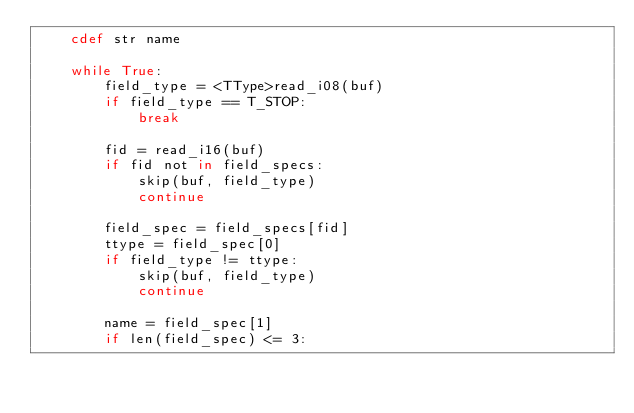<code> <loc_0><loc_0><loc_500><loc_500><_Cython_>    cdef str name

    while True:
        field_type = <TType>read_i08(buf)
        if field_type == T_STOP:
            break

        fid = read_i16(buf)
        if fid not in field_specs:
            skip(buf, field_type)
            continue

        field_spec = field_specs[fid]
        ttype = field_spec[0]
        if field_type != ttype:
            skip(buf, field_type)
            continue

        name = field_spec[1]
        if len(field_spec) <= 3:</code> 